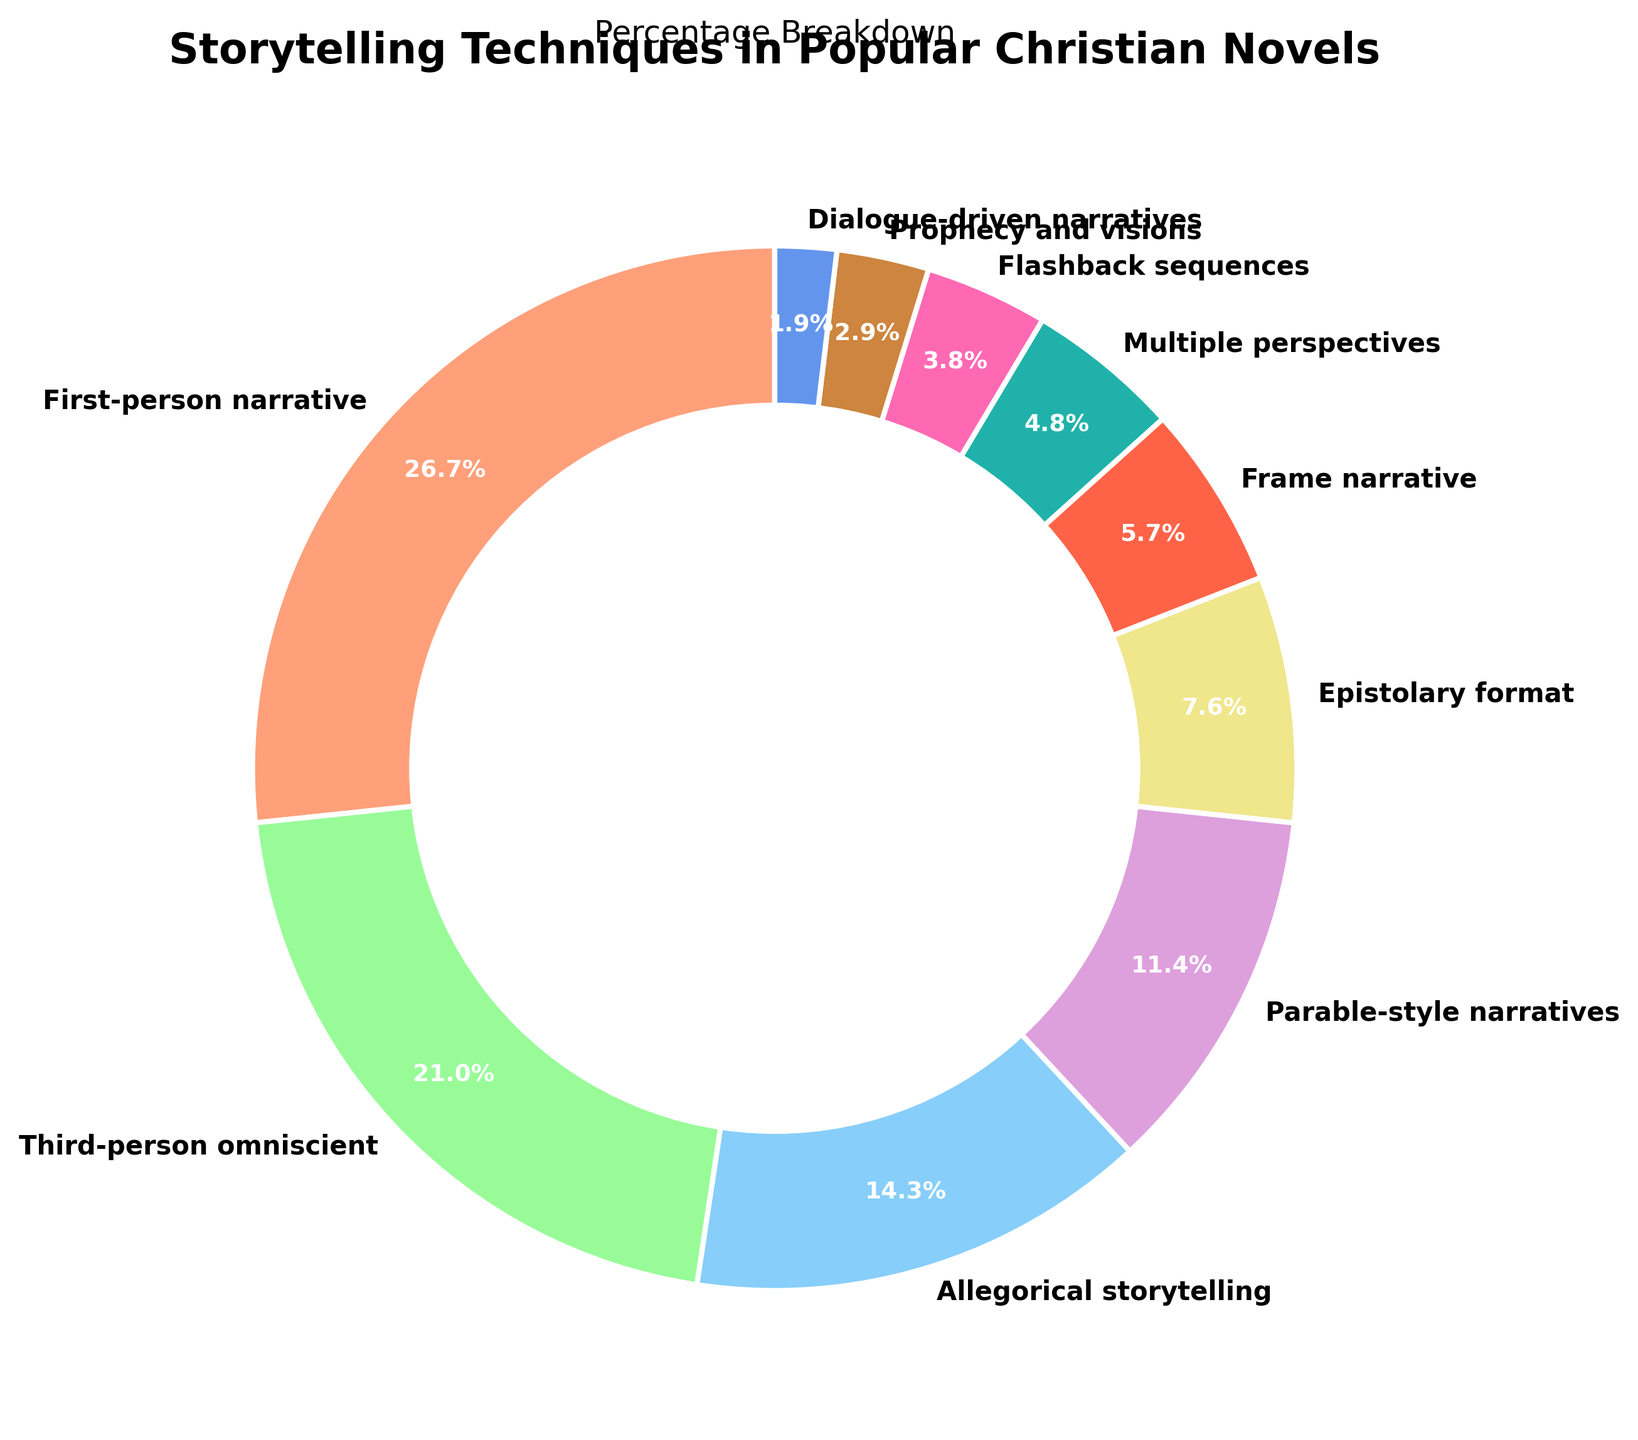Which technique has the highest percentage in the pie chart? The figure shows that the technique with the highest percentage is labeled "First-person narrative" with a percentage of 28%.
Answer: First-person narrative Which technique has the lowest percentage in the pie chart? Observing the figure, the technique with the smallest wedge is "Dialogue-driven narratives" at 2%.
Answer: Dialogue-driven narratives What is the combined percentage of third-person omniscient and parable-style narratives? In the figure, third-person omniscient is 22% and parable-style narratives is 12%. Adding these gives 22% + 12% = 34%.
Answer: 34% How much more common is first-person narrative compared to frame narrative? First-person narrative has a percentage of 28%, and frame narrative has 6%, so the difference is 28% - 6% = 22%.
Answer: 22% Which techniques together make up exactly 50% of the total? By examining the slices, first-person narrative (28%) and third-person omniscient (22%) together sum to 50%.
Answer: First-person narrative and third-person omniscient Which technique represents an 8% share in the breakdown? The figure shows that "Epistolary format" is the technique with an 8% share.
Answer: Epistolary format Are multiple perspectives more common than flashback sequences? The figure indicates that multiple perspectives have a 5% share, while flashback sequences have a 4% share, making multiple perspectives more common.
Answer: Yes What is the total percentage of all techniques categorized as non-narrative? Identifying non-narrative techniques such as "Allegorical storytelling" (15%), "Epistolary format" (8%), and "Dialogue-driven narratives" (2%) and summing them gives 15% + 8% + 2% = 25%.
Answer: 25% Which technique is represented by a green color and what is its percentage? The slice colored green corresponds to "Third-person omniscient," which has a percentage share of 22%.
Answer: Third-person omniscient, 22% If prophecies and visions were doubled in popularity, what would their new percentage be? Prophecy and visions currently has a 3% share. Doubling this would result in 3% * 2 = 6%.
Answer: 6% 